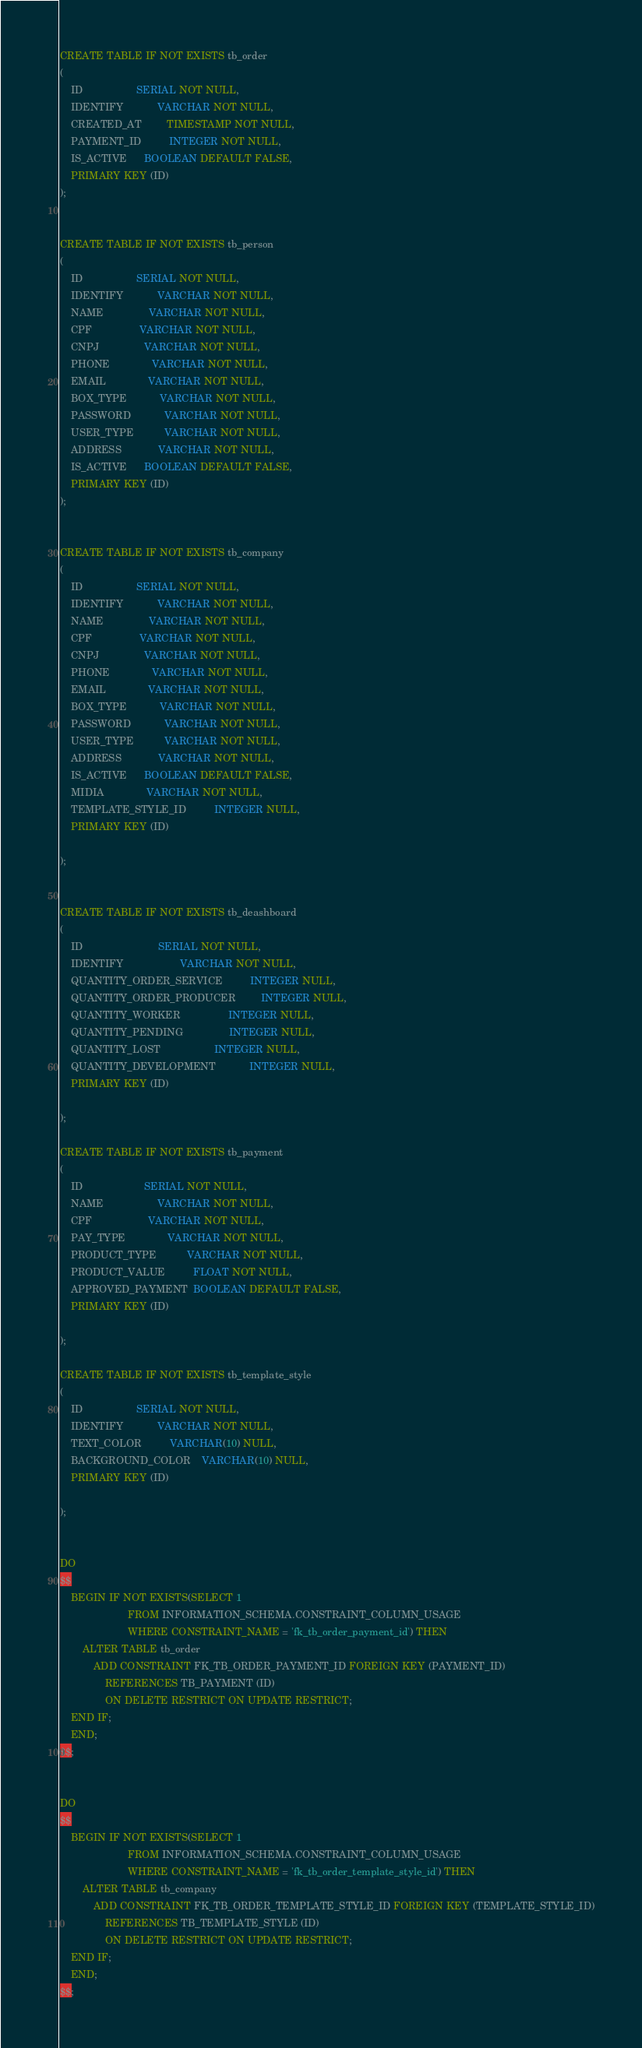<code> <loc_0><loc_0><loc_500><loc_500><_SQL_>CREATE TABLE IF NOT EXISTS tb_order
(
    ID                   SERIAL NOT NULL,
    IDENTIFY            VARCHAR NOT NULL,
    CREATED_AT         TIMESTAMP NOT NULL,
    PAYMENT_ID          INTEGER NOT NULL,
    IS_ACTIVE      BOOLEAN DEFAULT FALSE,
    PRIMARY KEY (ID)
);


CREATE TABLE IF NOT EXISTS tb_person
(
    ID                   SERIAL NOT NULL,
    IDENTIFY            VARCHAR NOT NULL,
    NAME                VARCHAR NOT NULL,
    CPF                 VARCHAR NOT NULL,
    CNPJ                VARCHAR NOT NULL,
    PHONE               VARCHAR NOT NULL,
    EMAIL               VARCHAR NOT NULL,
    BOX_TYPE            VARCHAR NOT NULL,
    PASSWORD            VARCHAR NOT NULL,
    USER_TYPE           VARCHAR NOT NULL,
    ADDRESS             VARCHAR NOT NULL,
    IS_ACTIVE      BOOLEAN DEFAULT FALSE,
    PRIMARY KEY (ID)
);


CREATE TABLE IF NOT EXISTS tb_company
(
    ID                   SERIAL NOT NULL,
    IDENTIFY            VARCHAR NOT NULL,
    NAME                VARCHAR NOT NULL,
    CPF                 VARCHAR NOT NULL,
    CNPJ                VARCHAR NOT NULL,
    PHONE               VARCHAR NOT NULL,
    EMAIL               VARCHAR NOT NULL,
    BOX_TYPE            VARCHAR NOT NULL,
    PASSWORD            VARCHAR NOT NULL,
    USER_TYPE           VARCHAR NOT NULL,
    ADDRESS             VARCHAR NOT NULL,
    IS_ACTIVE      BOOLEAN DEFAULT FALSE,
    MIDIA               VARCHAR NOT NULL,
    TEMPLATE_STYLE_ID          INTEGER NULL,
    PRIMARY KEY (ID)

);


CREATE TABLE IF NOT EXISTS tb_deashboard
(
    ID                           SERIAL NOT NULL,
    IDENTIFY                    VARCHAR NOT NULL,
    QUANTITY_ORDER_SERVICE          INTEGER NULL,
    QUANTITY_ORDER_PRODUCER         INTEGER NULL,
    QUANTITY_WORKER                 INTEGER NULL,
    QUANTITY_PENDING                INTEGER NULL,
    QUANTITY_LOST                   INTEGER NULL,
    QUANTITY_DEVELOPMENT            INTEGER NULL,
    PRIMARY KEY (ID)

);

CREATE TABLE IF NOT EXISTS tb_payment
(
    ID                      SERIAL NOT NULL,
    NAME                   VARCHAR NOT NULL,
    CPF                    VARCHAR NOT NULL,
    PAY_TYPE               VARCHAR NOT NULL,
    PRODUCT_TYPE           VARCHAR NOT NULL,
    PRODUCT_VALUE          FLOAT NOT NULL,
    APPROVED_PAYMENT  BOOLEAN DEFAULT FALSE,
    PRIMARY KEY (ID)

);

CREATE TABLE IF NOT EXISTS tb_template_style
(
    ID                   SERIAL NOT NULL,
    IDENTIFY            VARCHAR NOT NULL,
    TEXT_COLOR          VARCHAR(10) NULL,
    BACKGROUND_COLOR    VARCHAR(10) NULL,
    PRIMARY KEY (ID)

);


DO
$$
    BEGIN IF NOT EXISTS(SELECT 1
                        FROM INFORMATION_SCHEMA.CONSTRAINT_COLUMN_USAGE
                        WHERE CONSTRAINT_NAME = 'fk_tb_order_payment_id') THEN
        ALTER TABLE tb_order
            ADD CONSTRAINT FK_TB_ORDER_PAYMENT_ID FOREIGN KEY (PAYMENT_ID)
                REFERENCES TB_PAYMENT (ID)
                ON DELETE RESTRICT ON UPDATE RESTRICT;
    END IF;
    END;
$$;


DO
$$
    BEGIN IF NOT EXISTS(SELECT 1
                        FROM INFORMATION_SCHEMA.CONSTRAINT_COLUMN_USAGE
                        WHERE CONSTRAINT_NAME = 'fk_tb_order_template_style_id') THEN
        ALTER TABLE tb_company
            ADD CONSTRAINT FK_TB_ORDER_TEMPLATE_STYLE_ID FOREIGN KEY (TEMPLATE_STYLE_ID)
                REFERENCES TB_TEMPLATE_STYLE (ID)
                ON DELETE RESTRICT ON UPDATE RESTRICT;
    END IF;
    END;
$$;</code> 